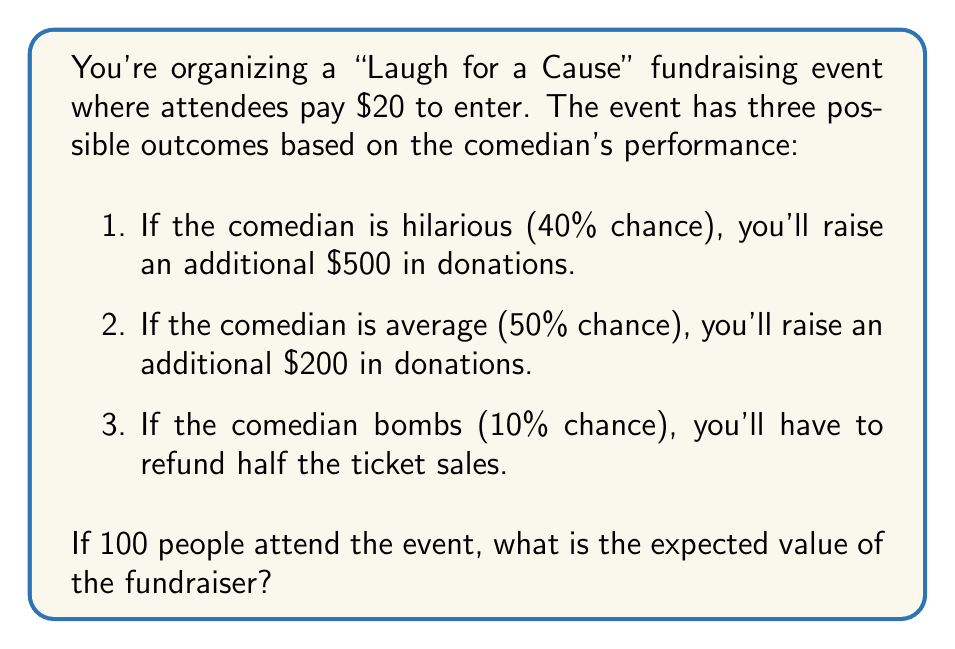Help me with this question. Let's approach this step-by-step:

1. Calculate the base ticket sales:
   $$\text{Base sales} = 100 \text{ people} \times \$20 = \$2000$$

2. Calculate the expected value for each outcome:

   a) Hilarious outcome (40% chance):
      $$E(\text{hilarious}) = 0.40 \times (\$2000 + \$500) = \$1000$$

   b) Average outcome (50% chance):
      $$E(\text{average}) = 0.50 \times (\$2000 + \$200) = \$1100$$

   c) Bombs outcome (10% chance):
      $$E(\text{bombs}) = 0.10 \times (\$2000 \times 0.5) = \$100$$

3. Sum up the expected values:
   $$E(\text{total}) = E(\text{hilarious}) + E(\text{average}) + E(\text{bombs})$$
   $$E(\text{total}) = \$1000 + \$1100 + \$100 = \$2200$$

The expected value of the fundraiser is $2200.
Answer: $2200 